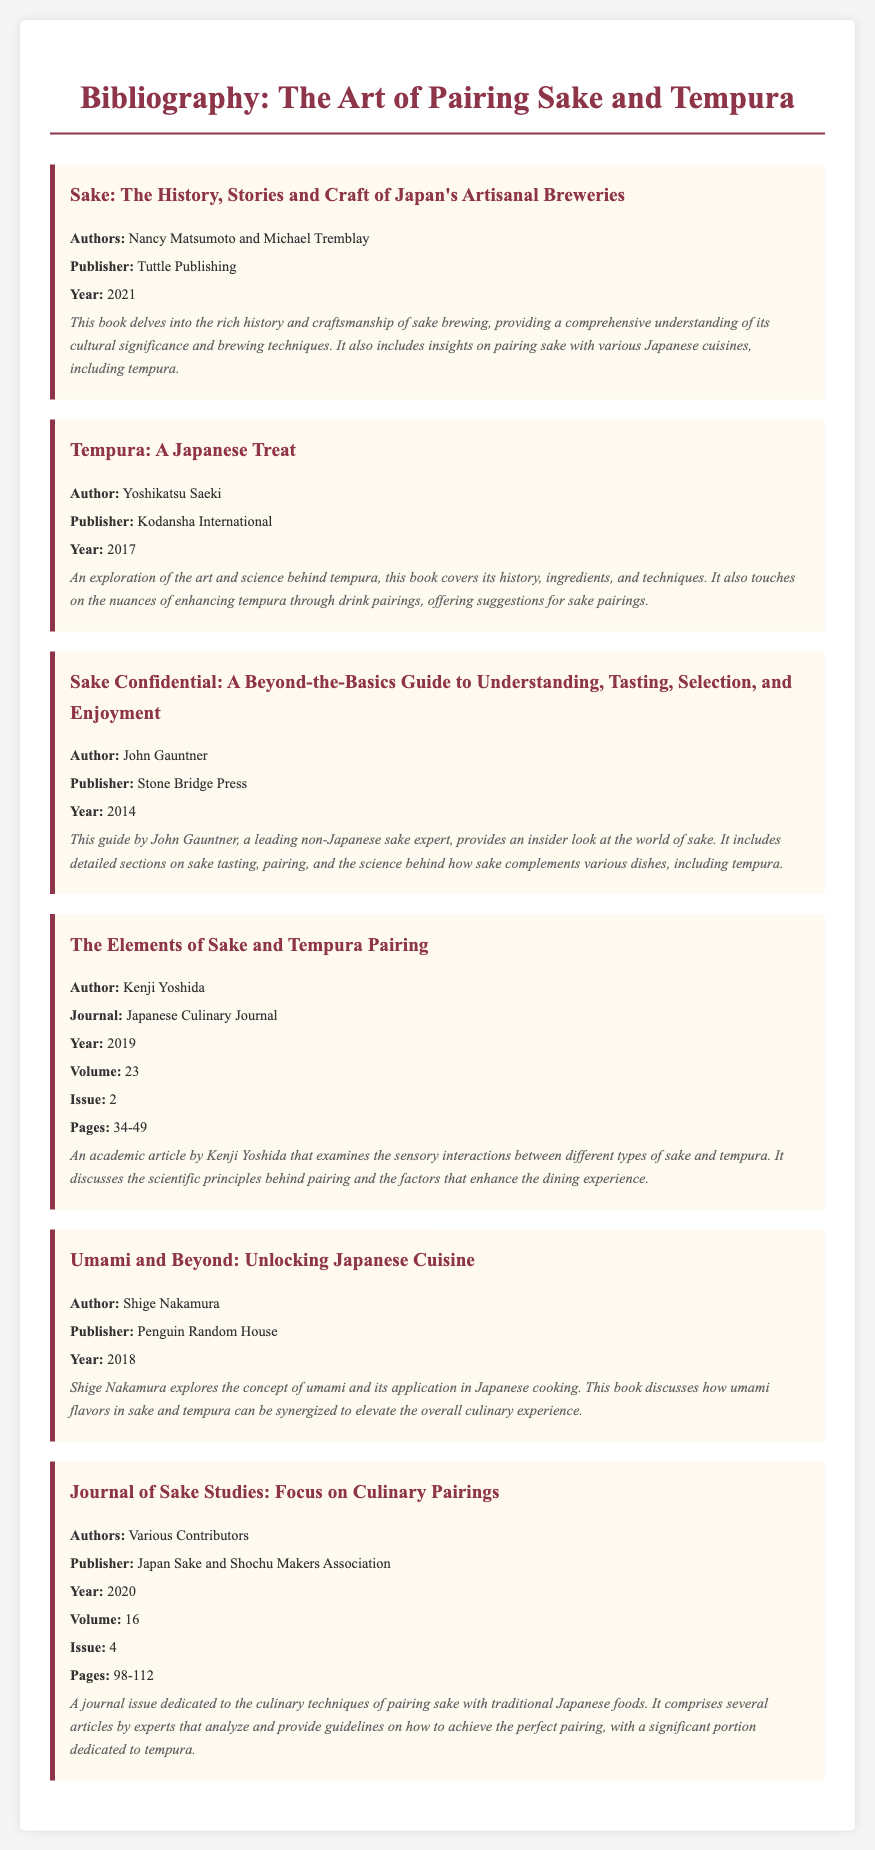What is the title of the document? The title is prominently displayed at the top of the rendered document, indicating the main focus of the bibliography.
Answer: The Art of Pairing Sake and Tempura: A Comparative Study Who are the authors of the book "Sake: The History, Stories and Craft of Japan's Artisanal Breweries"? The authors are mentioned in the bibliographic entry for this book, which provides specific names related to its authorship.
Answer: Nancy Matsumoto and Michael Tremblay In what year was "Tempura: A Japanese Treat" published? The publication year is specified in the bibliographic entry and helps to contextualize the book's information within a timeline.
Answer: 2017 What volume and issue number is the article "The Elements of Sake and Tempura Pairing" published in? The volume and issue are listed in the bibliographic entry, indicating where the article can be found within the journal's series.
Answer: Volume 23, Issue 2 What is the publisher of "Sake Confidential"? The publisher is provided in the bibliographic details for clarity and to give credit to the publishing house responsible for the book's release.
Answer: Stone Bridge Press What type of publication is "Journal of Sake Studies: Focus on Culinary Pairings"? This question probes into the nature of the publication, helping to categorize it based on the bibliographic format provided.
Answer: Journal Why is "Umami and Beyond: Unlocking Japanese Cuisine" significant for pairing sake and tempura? This question requires drawing together ideas within the bibliographic entry about the book's content and its relevance to the pairing topic.
Answer: Discusses how umami flavors in sake and tempura can be synergized 